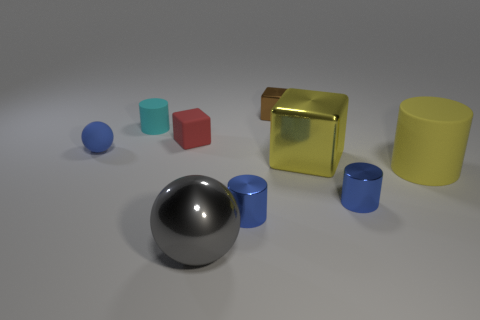Subtract all green cylinders. Subtract all brown spheres. How many cylinders are left? 4 Subtract all cubes. How many objects are left? 6 Subtract 1 yellow cylinders. How many objects are left? 8 Subtract all red rubber cubes. Subtract all red metal cubes. How many objects are left? 8 Add 7 small cyan objects. How many small cyan objects are left? 8 Add 1 spheres. How many spheres exist? 3 